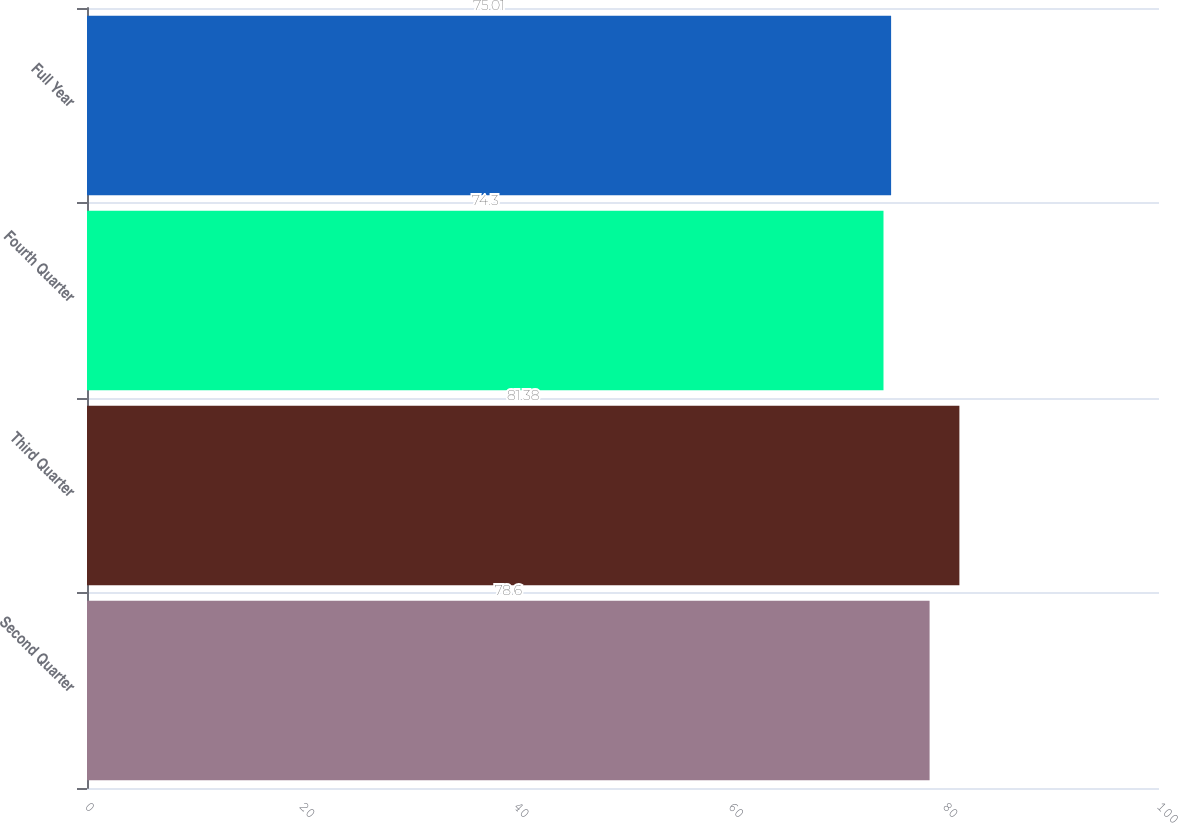Convert chart to OTSL. <chart><loc_0><loc_0><loc_500><loc_500><bar_chart><fcel>Second Quarter<fcel>Third Quarter<fcel>Fourth Quarter<fcel>Full Year<nl><fcel>78.6<fcel>81.38<fcel>74.3<fcel>75.01<nl></chart> 